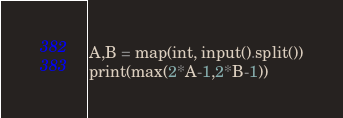Convert code to text. <code><loc_0><loc_0><loc_500><loc_500><_Python_>A,B = map(int, input().split())
print(max(2*A-1,2*B-1))</code> 